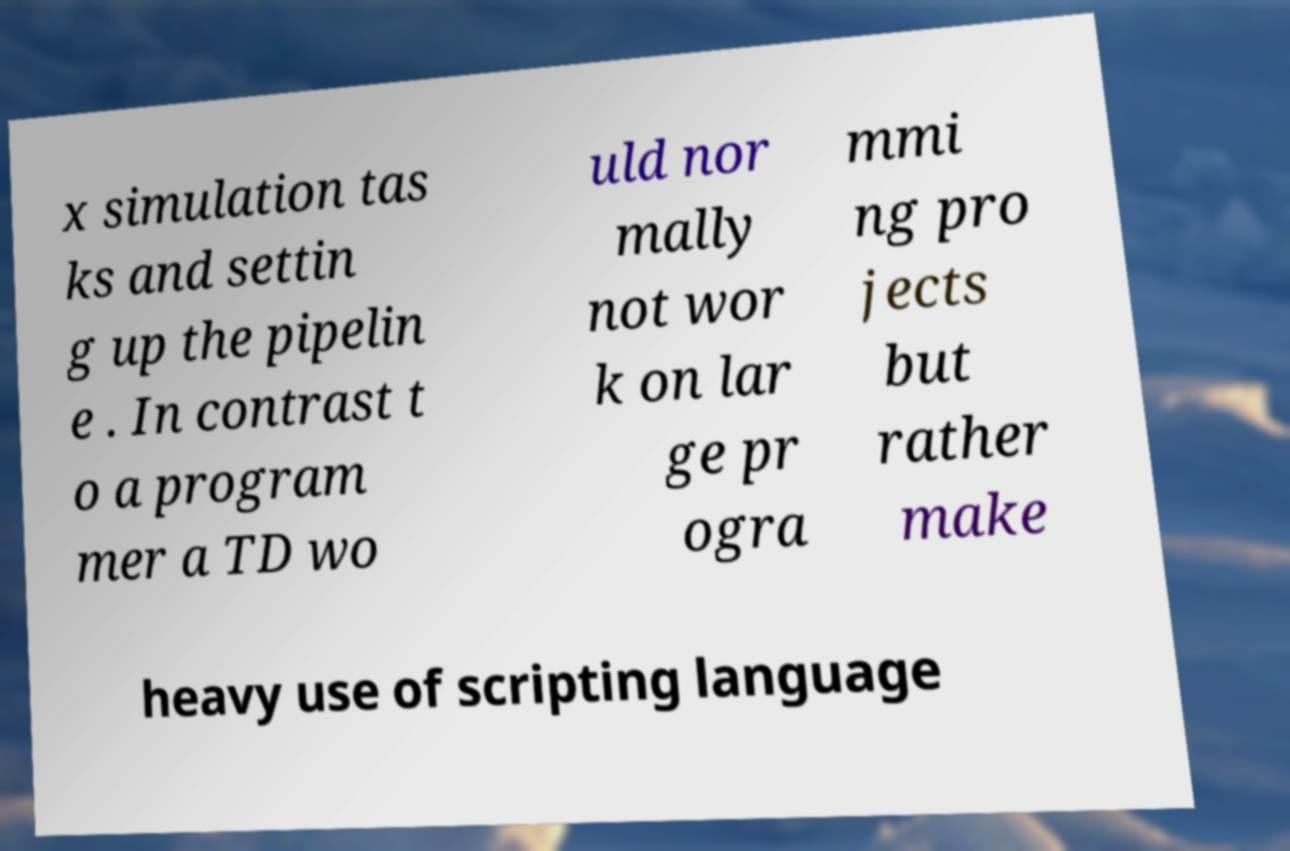Can you read and provide the text displayed in the image?This photo seems to have some interesting text. Can you extract and type it out for me? x simulation tas ks and settin g up the pipelin e . In contrast t o a program mer a TD wo uld nor mally not wor k on lar ge pr ogra mmi ng pro jects but rather make heavy use of scripting language 